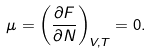Convert formula to latex. <formula><loc_0><loc_0><loc_500><loc_500>\mu = \left ( \frac { \partial F } { \partial N } \right ) _ { V , T } = 0 .</formula> 